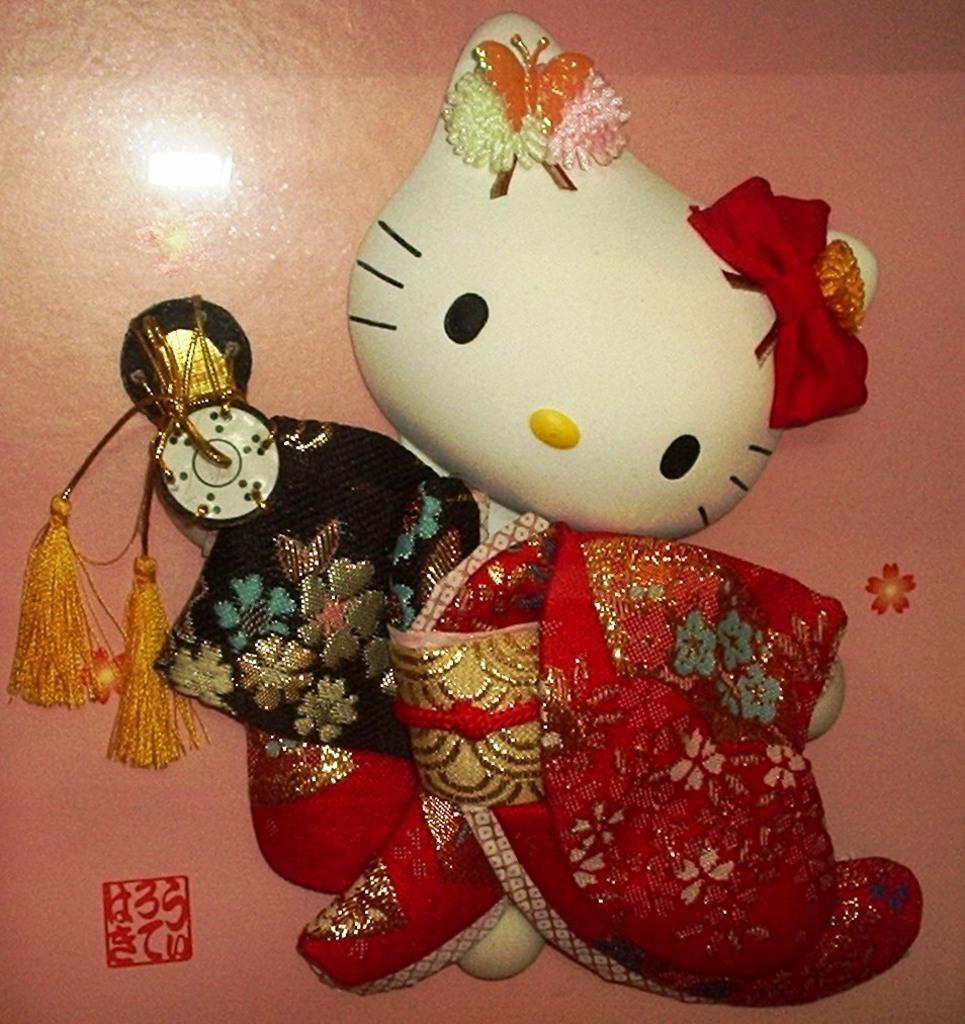In one or two sentences, can you explain what this image depicts? In this picture there is a toy cat in red cloth. The wall is painted right. 